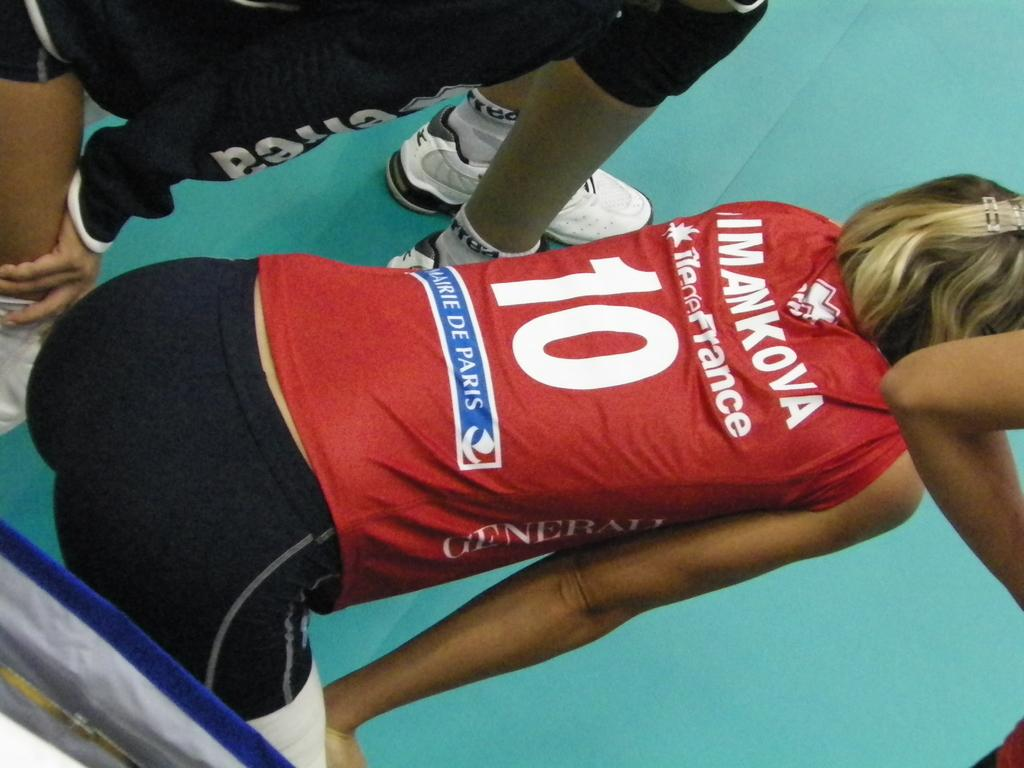<image>
Create a compact narrative representing the image presented. A woman wears a red top with the number 10 on the back. 